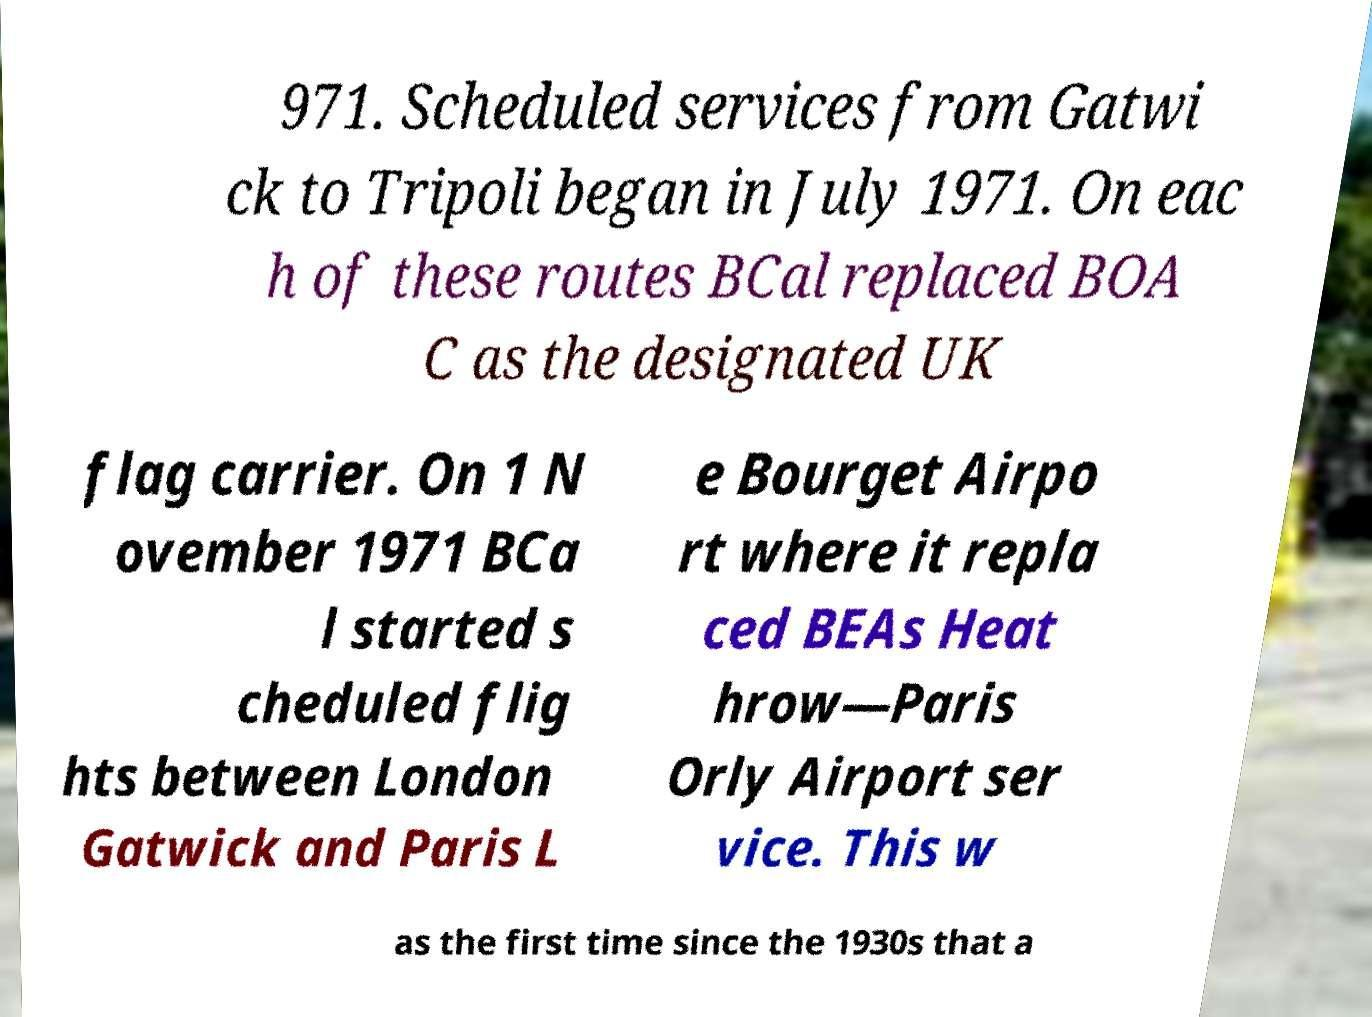Can you read and provide the text displayed in the image?This photo seems to have some interesting text. Can you extract and type it out for me? 971. Scheduled services from Gatwi ck to Tripoli began in July 1971. On eac h of these routes BCal replaced BOA C as the designated UK flag carrier. On 1 N ovember 1971 BCa l started s cheduled flig hts between London Gatwick and Paris L e Bourget Airpo rt where it repla ced BEAs Heat hrow—Paris Orly Airport ser vice. This w as the first time since the 1930s that a 